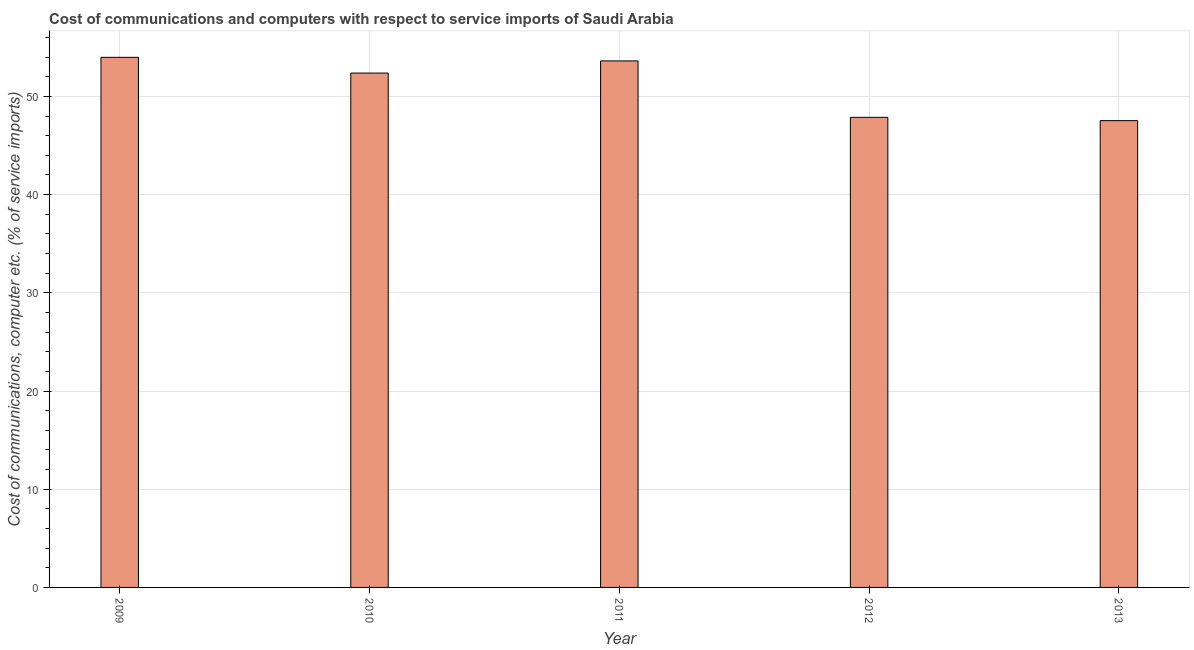Does the graph contain any zero values?
Provide a succinct answer. No. Does the graph contain grids?
Ensure brevity in your answer.  Yes. What is the title of the graph?
Offer a very short reply. Cost of communications and computers with respect to service imports of Saudi Arabia. What is the label or title of the Y-axis?
Your answer should be very brief. Cost of communications, computer etc. (% of service imports). What is the cost of communications and computer in 2012?
Your answer should be very brief. 47.87. Across all years, what is the maximum cost of communications and computer?
Your answer should be compact. 53.98. Across all years, what is the minimum cost of communications and computer?
Offer a terse response. 47.53. In which year was the cost of communications and computer minimum?
Ensure brevity in your answer.  2013. What is the sum of the cost of communications and computer?
Make the answer very short. 255.38. What is the difference between the cost of communications and computer in 2009 and 2010?
Provide a short and direct response. 1.6. What is the average cost of communications and computer per year?
Your answer should be compact. 51.08. What is the median cost of communications and computer?
Your answer should be very brief. 52.38. Is the cost of communications and computer in 2009 less than that in 2011?
Your response must be concise. No. What is the difference between the highest and the second highest cost of communications and computer?
Keep it short and to the point. 0.36. Is the sum of the cost of communications and computer in 2010 and 2013 greater than the maximum cost of communications and computer across all years?
Offer a terse response. Yes. What is the difference between the highest and the lowest cost of communications and computer?
Offer a very short reply. 6.45. Are all the bars in the graph horizontal?
Your answer should be very brief. No. How many years are there in the graph?
Provide a succinct answer. 5. What is the difference between two consecutive major ticks on the Y-axis?
Your answer should be compact. 10. Are the values on the major ticks of Y-axis written in scientific E-notation?
Provide a short and direct response. No. What is the Cost of communications, computer etc. (% of service imports) of 2009?
Give a very brief answer. 53.98. What is the Cost of communications, computer etc. (% of service imports) of 2010?
Ensure brevity in your answer.  52.38. What is the Cost of communications, computer etc. (% of service imports) in 2011?
Provide a succinct answer. 53.62. What is the Cost of communications, computer etc. (% of service imports) in 2012?
Your answer should be very brief. 47.87. What is the Cost of communications, computer etc. (% of service imports) in 2013?
Provide a succinct answer. 47.53. What is the difference between the Cost of communications, computer etc. (% of service imports) in 2009 and 2010?
Your answer should be very brief. 1.6. What is the difference between the Cost of communications, computer etc. (% of service imports) in 2009 and 2011?
Your answer should be compact. 0.37. What is the difference between the Cost of communications, computer etc. (% of service imports) in 2009 and 2012?
Offer a very short reply. 6.11. What is the difference between the Cost of communications, computer etc. (% of service imports) in 2009 and 2013?
Ensure brevity in your answer.  6.45. What is the difference between the Cost of communications, computer etc. (% of service imports) in 2010 and 2011?
Your answer should be very brief. -1.24. What is the difference between the Cost of communications, computer etc. (% of service imports) in 2010 and 2012?
Provide a short and direct response. 4.51. What is the difference between the Cost of communications, computer etc. (% of service imports) in 2010 and 2013?
Your answer should be compact. 4.84. What is the difference between the Cost of communications, computer etc. (% of service imports) in 2011 and 2012?
Ensure brevity in your answer.  5.75. What is the difference between the Cost of communications, computer etc. (% of service imports) in 2011 and 2013?
Your response must be concise. 6.08. What is the difference between the Cost of communications, computer etc. (% of service imports) in 2012 and 2013?
Provide a succinct answer. 0.33. What is the ratio of the Cost of communications, computer etc. (% of service imports) in 2009 to that in 2010?
Make the answer very short. 1.03. What is the ratio of the Cost of communications, computer etc. (% of service imports) in 2009 to that in 2011?
Make the answer very short. 1.01. What is the ratio of the Cost of communications, computer etc. (% of service imports) in 2009 to that in 2012?
Your answer should be very brief. 1.13. What is the ratio of the Cost of communications, computer etc. (% of service imports) in 2009 to that in 2013?
Make the answer very short. 1.14. What is the ratio of the Cost of communications, computer etc. (% of service imports) in 2010 to that in 2012?
Your answer should be compact. 1.09. What is the ratio of the Cost of communications, computer etc. (% of service imports) in 2010 to that in 2013?
Keep it short and to the point. 1.1. What is the ratio of the Cost of communications, computer etc. (% of service imports) in 2011 to that in 2012?
Your answer should be very brief. 1.12. What is the ratio of the Cost of communications, computer etc. (% of service imports) in 2011 to that in 2013?
Give a very brief answer. 1.13. What is the ratio of the Cost of communications, computer etc. (% of service imports) in 2012 to that in 2013?
Make the answer very short. 1.01. 